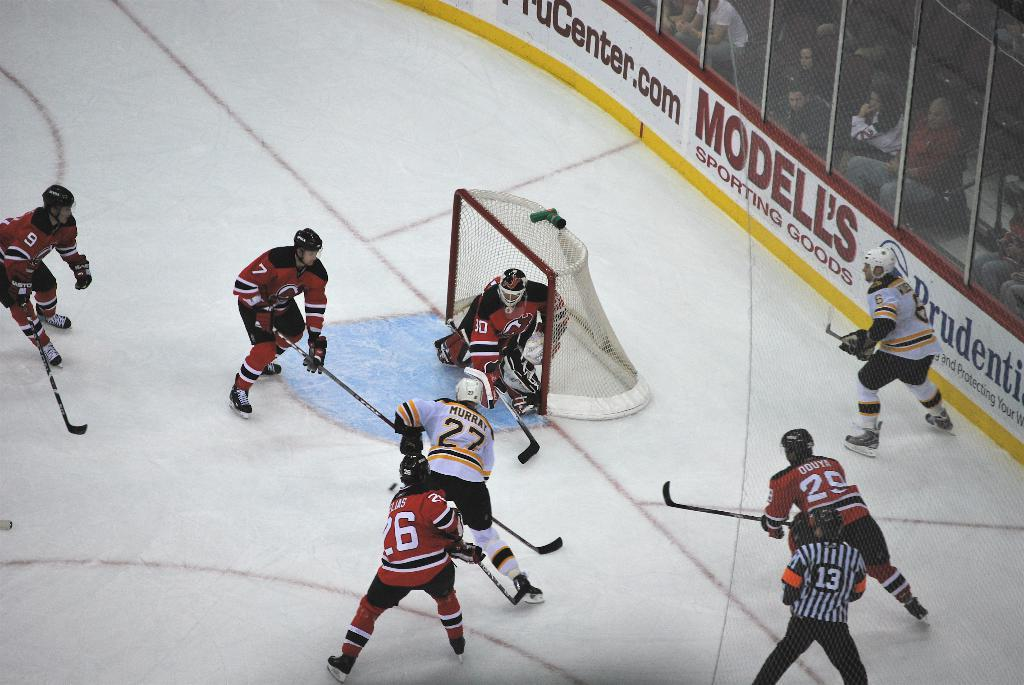Provide a one-sentence caption for the provided image. A hockey game is being played in a stadium which features an advertisement for Modell's Sporting Goods. 